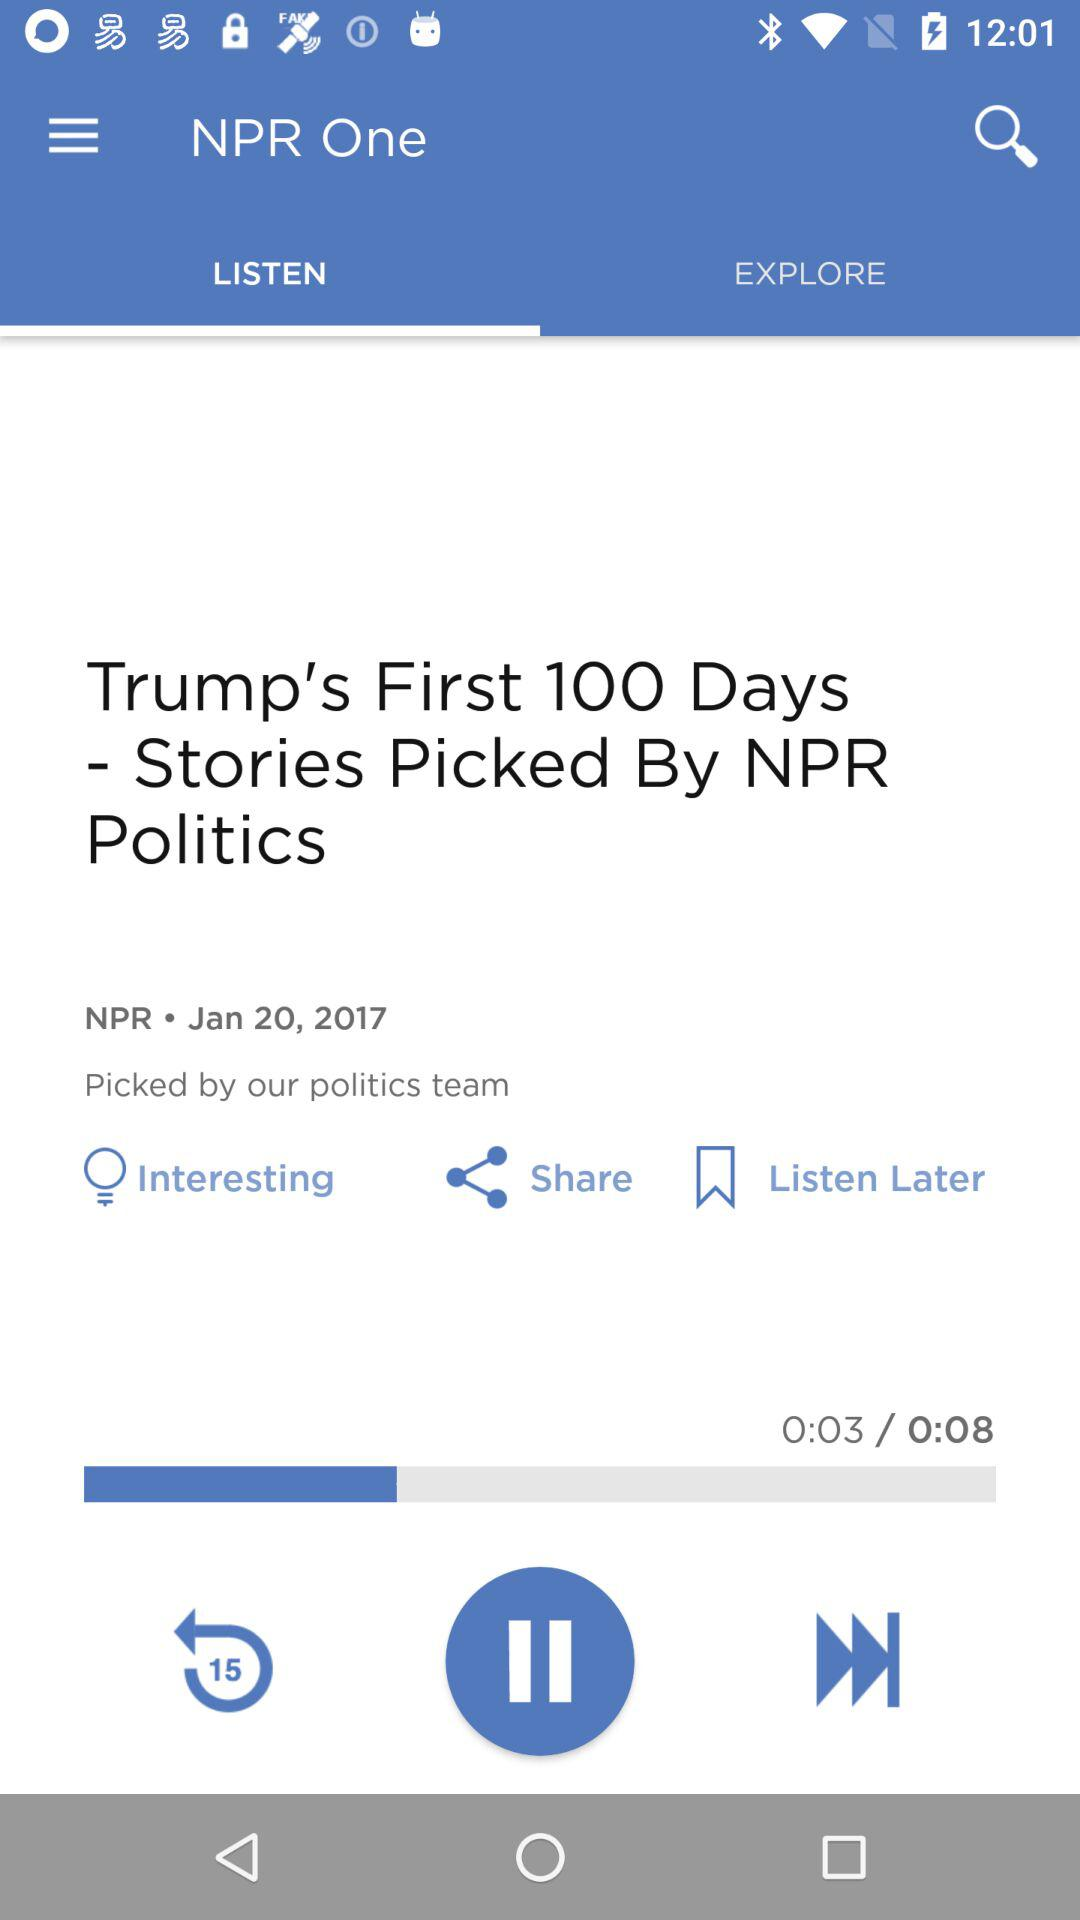Which tab is selected? The selected tab is "LISTEN". 